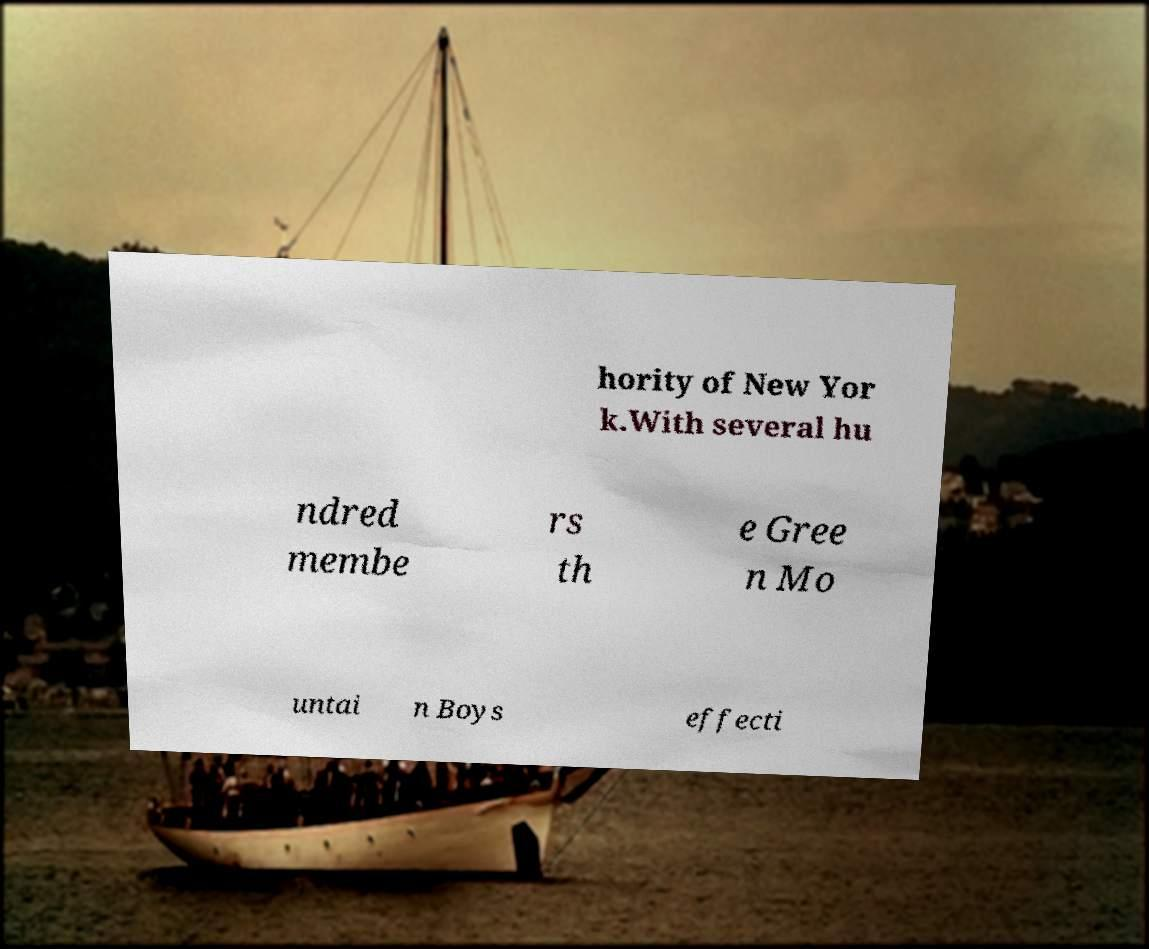Please identify and transcribe the text found in this image. hority of New Yor k.With several hu ndred membe rs th e Gree n Mo untai n Boys effecti 